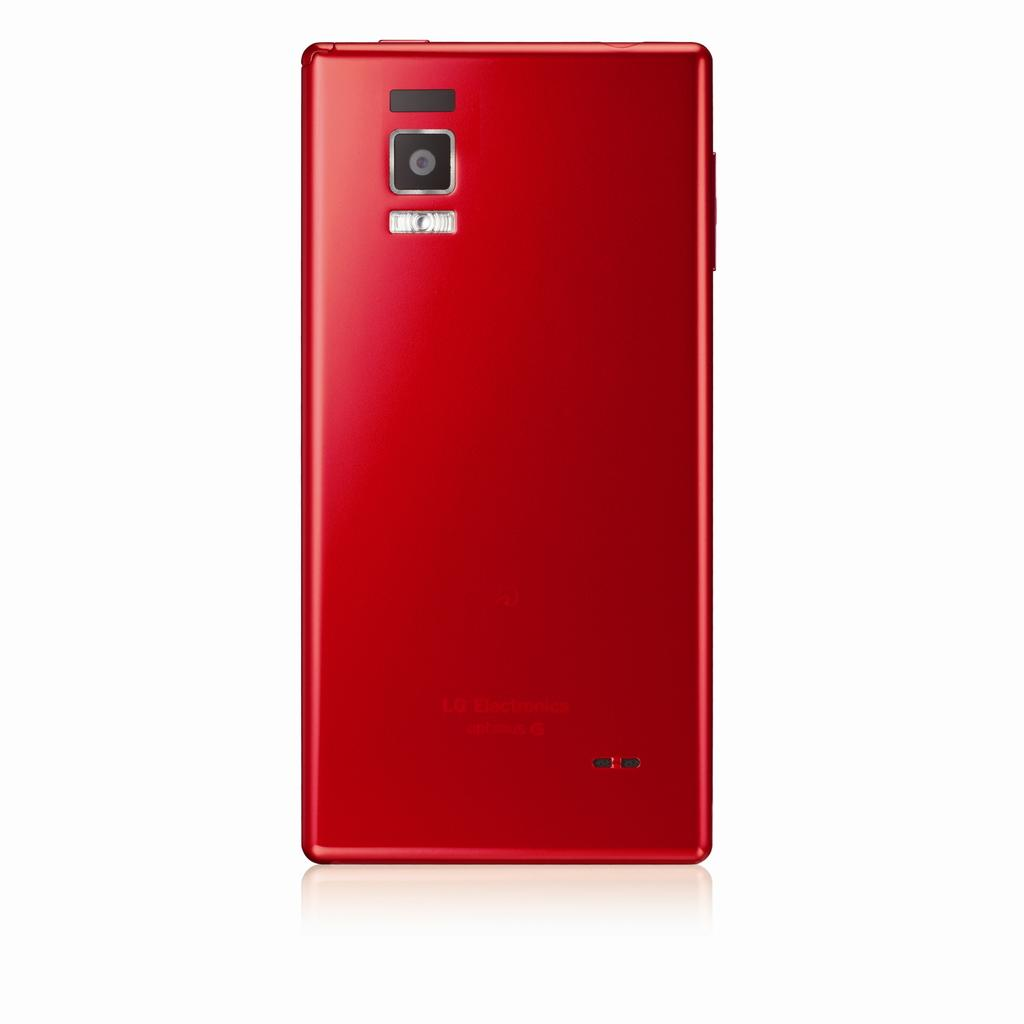<image>
Describe the image concisely. red lg electronics optimus g cell phone against a white background 